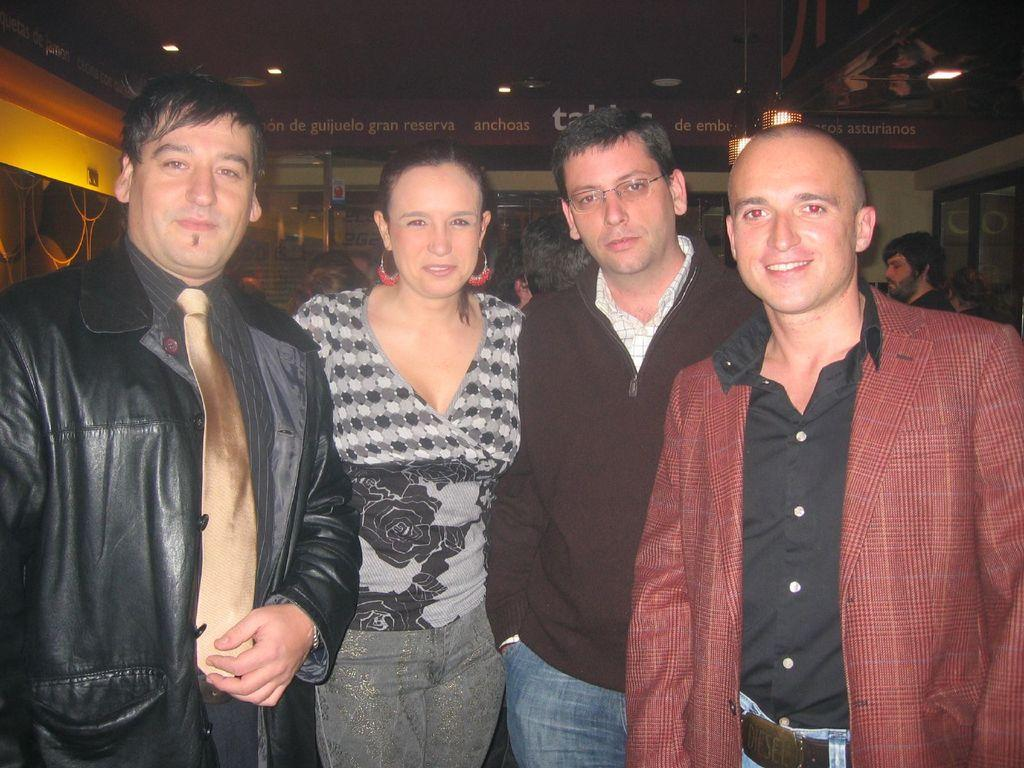How many people are in the image? There is a group of persons in the image. What are the persons in the image doing? The persons are standing and smiling. What type of lighting is present in the image? There are ceiling lights in the image. What is visible above the persons in the image? There is a roof visible in the image. What type of mailbox can be seen near the persons in the image? There is no mailbox present in the image. What religious symbols can be seen in the image? There are no religious symbols visible in the image. 